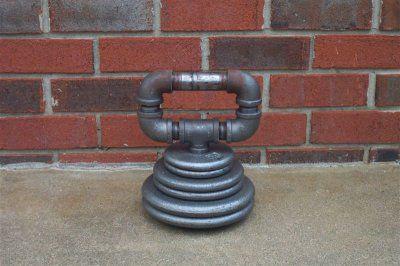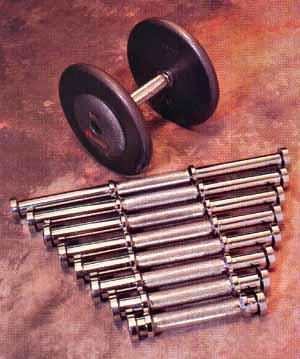The first image is the image on the left, the second image is the image on the right. Analyze the images presented: Is the assertion "there is a dumb bell laying on a wood floor next to 12 seperate circular flat weights" valid? Answer yes or no. No. 